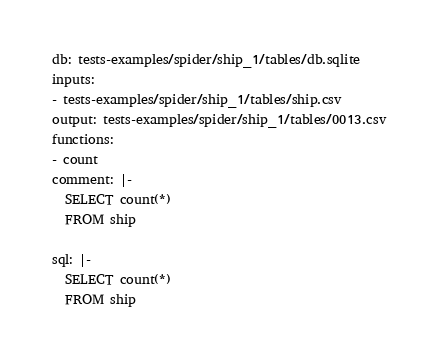<code> <loc_0><loc_0><loc_500><loc_500><_YAML_>db: tests-examples/spider/ship_1/tables/db.sqlite
inputs:
- tests-examples/spider/ship_1/tables/ship.csv
output: tests-examples/spider/ship_1/tables/0013.csv
functions:
- count
comment: |-
  SELECT count(*)
  FROM ship

sql: |-
  SELECT count(*)
  FROM ship</code> 